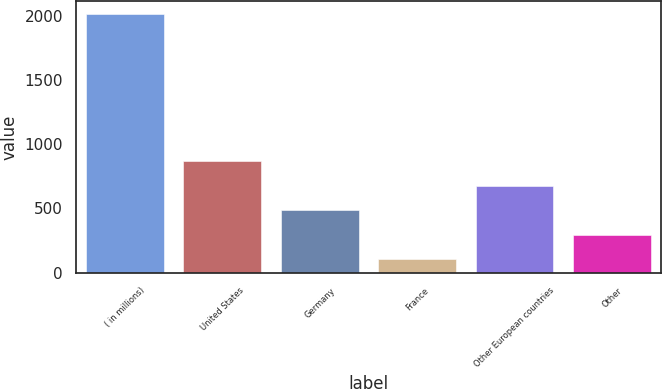<chart> <loc_0><loc_0><loc_500><loc_500><bar_chart><fcel>( in millions)<fcel>United States<fcel>Germany<fcel>France<fcel>Other European countries<fcel>Other<nl><fcel>2012<fcel>866.36<fcel>484.48<fcel>102.6<fcel>675.42<fcel>293.54<nl></chart> 